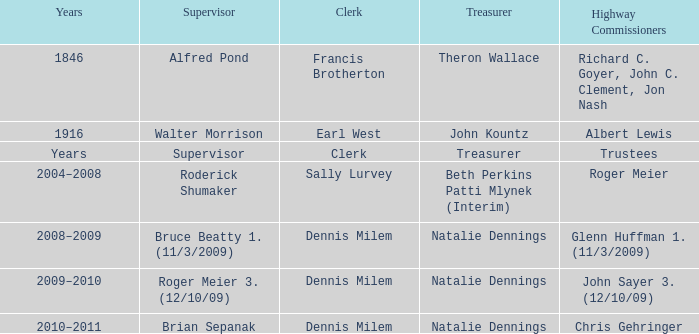Who was the supervisor in the year 1846? Alfred Pond. 